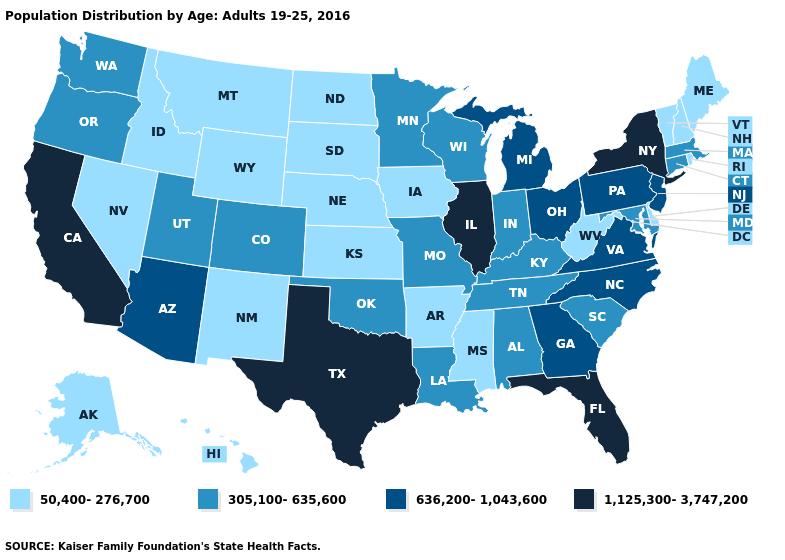Does the first symbol in the legend represent the smallest category?
Short answer required. Yes. Does Colorado have the lowest value in the West?
Concise answer only. No. What is the lowest value in the West?
Short answer required. 50,400-276,700. What is the value of Idaho?
Short answer required. 50,400-276,700. Among the states that border Nebraska , which have the highest value?
Concise answer only. Colorado, Missouri. Among the states that border Ohio , which have the lowest value?
Be succinct. West Virginia. What is the highest value in the South ?
Write a very short answer. 1,125,300-3,747,200. How many symbols are there in the legend?
Answer briefly. 4. What is the value of Louisiana?
Keep it brief. 305,100-635,600. What is the value of Oregon?
Give a very brief answer. 305,100-635,600. Which states have the highest value in the USA?
Answer briefly. California, Florida, Illinois, New York, Texas. Name the states that have a value in the range 305,100-635,600?
Answer briefly. Alabama, Colorado, Connecticut, Indiana, Kentucky, Louisiana, Maryland, Massachusetts, Minnesota, Missouri, Oklahoma, Oregon, South Carolina, Tennessee, Utah, Washington, Wisconsin. Among the states that border Tennessee , does Missouri have the highest value?
Answer briefly. No. What is the value of Wyoming?
Write a very short answer. 50,400-276,700. Which states have the lowest value in the USA?
Be succinct. Alaska, Arkansas, Delaware, Hawaii, Idaho, Iowa, Kansas, Maine, Mississippi, Montana, Nebraska, Nevada, New Hampshire, New Mexico, North Dakota, Rhode Island, South Dakota, Vermont, West Virginia, Wyoming. 